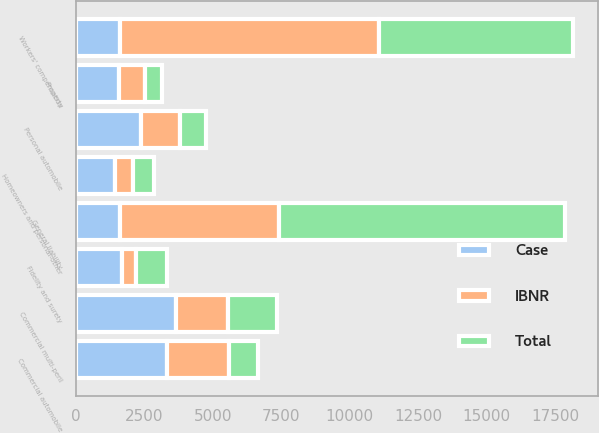Convert chart to OTSL. <chart><loc_0><loc_0><loc_500><loc_500><stacked_bar_chart><ecel><fcel>General liability<fcel>Property<fcel>Commercial multi-peril<fcel>Commercial automobile<fcel>Workers' compensation<fcel>Fidelity and surety<fcel>Personal automobile<fcel>Homeowners and personal-other<nl><fcel>IBNR<fcel>5809<fcel>945<fcel>1897<fcel>2256<fcel>9447<fcel>542<fcel>1434<fcel>653<nl><fcel>Total<fcel>10449<fcel>627<fcel>1766<fcel>1060<fcel>7082<fcel>1124<fcel>935<fcel>769<nl><fcel>Case<fcel>1619<fcel>1572<fcel>3663<fcel>3316<fcel>1619<fcel>1666<fcel>2369<fcel>1422<nl></chart> 